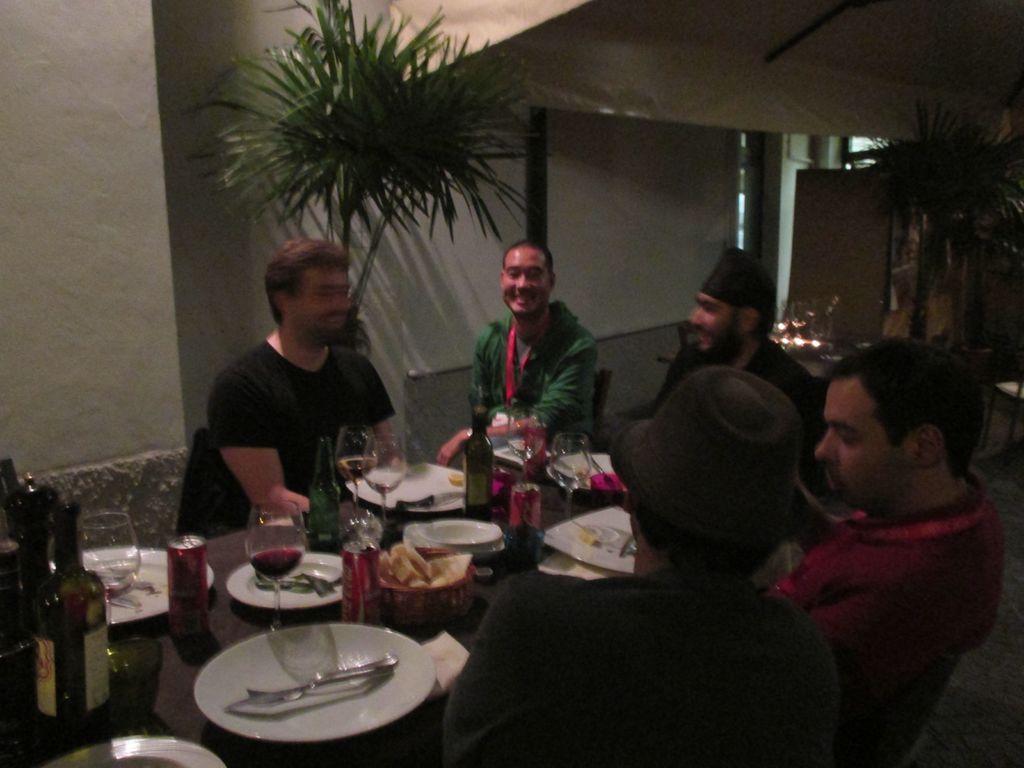Please provide a concise description of this image. This is a picture taken in a restaurant. In the foreground of the picture there is a table, on the table there are plates, glasses, bottles, spoons, bowls. There are people seated around the table. On the right there is a plant and in the center there is another plant. In the background there is wall. 